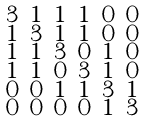<formula> <loc_0><loc_0><loc_500><loc_500>\begin{smallmatrix} 3 & 1 & 1 & 1 & 0 & 0 \\ 1 & 3 & 1 & 1 & 0 & 0 \\ 1 & 1 & 3 & 0 & 1 & 0 \\ 1 & 1 & 0 & 3 & 1 & 0 \\ 0 & 0 & 1 & 1 & 3 & 1 \\ 0 & 0 & 0 & 0 & 1 & 3 \end{smallmatrix}</formula> 